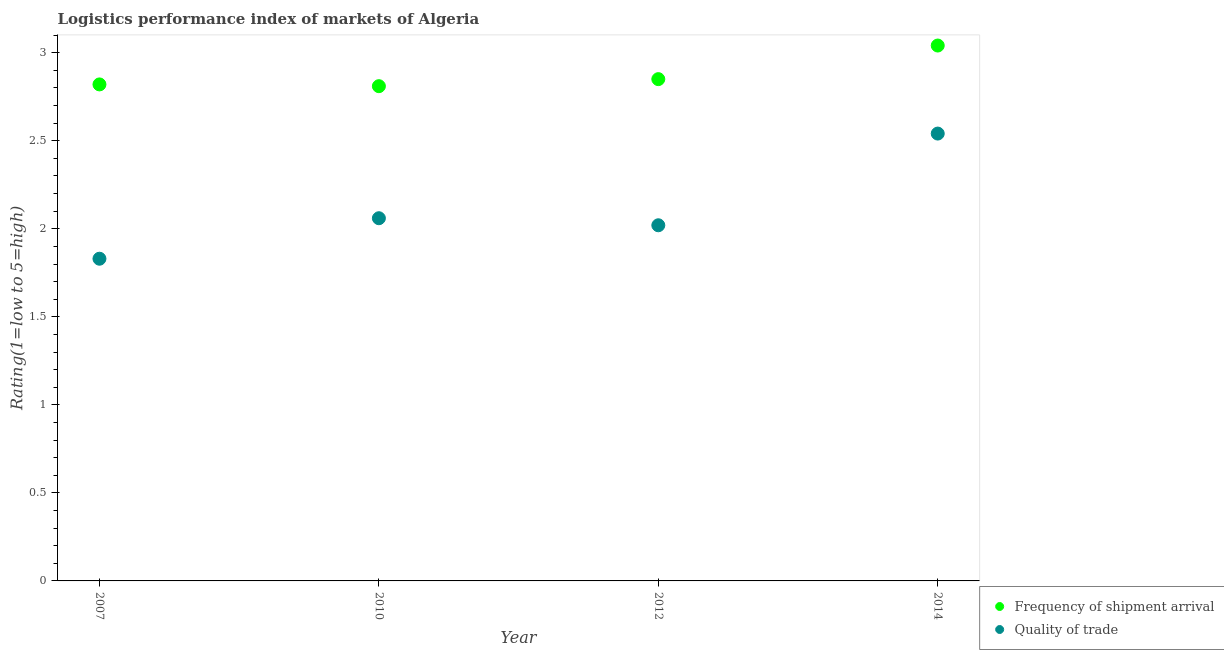How many different coloured dotlines are there?
Your response must be concise. 2. Is the number of dotlines equal to the number of legend labels?
Give a very brief answer. Yes. What is the lpi quality of trade in 2014?
Provide a short and direct response. 2.54. Across all years, what is the maximum lpi quality of trade?
Offer a terse response. 2.54. Across all years, what is the minimum lpi quality of trade?
Provide a short and direct response. 1.83. What is the total lpi of frequency of shipment arrival in the graph?
Provide a short and direct response. 11.52. What is the difference between the lpi of frequency of shipment arrival in 2012 and that in 2014?
Your answer should be compact. -0.19. What is the difference between the lpi quality of trade in 2010 and the lpi of frequency of shipment arrival in 2014?
Make the answer very short. -0.98. What is the average lpi quality of trade per year?
Offer a terse response. 2.11. In the year 2012, what is the difference between the lpi of frequency of shipment arrival and lpi quality of trade?
Provide a succinct answer. 0.83. What is the ratio of the lpi quality of trade in 2007 to that in 2014?
Make the answer very short. 0.72. Is the lpi quality of trade in 2007 less than that in 2012?
Offer a terse response. Yes. What is the difference between the highest and the second highest lpi of frequency of shipment arrival?
Give a very brief answer. 0.19. What is the difference between the highest and the lowest lpi of frequency of shipment arrival?
Make the answer very short. 0.23. Is the lpi quality of trade strictly greater than the lpi of frequency of shipment arrival over the years?
Keep it short and to the point. No. Is the lpi quality of trade strictly less than the lpi of frequency of shipment arrival over the years?
Offer a very short reply. Yes. How many dotlines are there?
Offer a terse response. 2. How many years are there in the graph?
Provide a short and direct response. 4. Does the graph contain any zero values?
Keep it short and to the point. No. Where does the legend appear in the graph?
Keep it short and to the point. Bottom right. How are the legend labels stacked?
Keep it short and to the point. Vertical. What is the title of the graph?
Offer a very short reply. Logistics performance index of markets of Algeria. What is the label or title of the X-axis?
Offer a terse response. Year. What is the label or title of the Y-axis?
Your answer should be very brief. Rating(1=low to 5=high). What is the Rating(1=low to 5=high) of Frequency of shipment arrival in 2007?
Give a very brief answer. 2.82. What is the Rating(1=low to 5=high) in Quality of trade in 2007?
Your answer should be compact. 1.83. What is the Rating(1=low to 5=high) in Frequency of shipment arrival in 2010?
Ensure brevity in your answer.  2.81. What is the Rating(1=low to 5=high) of Quality of trade in 2010?
Give a very brief answer. 2.06. What is the Rating(1=low to 5=high) of Frequency of shipment arrival in 2012?
Your response must be concise. 2.85. What is the Rating(1=low to 5=high) of Quality of trade in 2012?
Offer a terse response. 2.02. What is the Rating(1=low to 5=high) in Frequency of shipment arrival in 2014?
Provide a succinct answer. 3.04. What is the Rating(1=low to 5=high) in Quality of trade in 2014?
Give a very brief answer. 2.54. Across all years, what is the maximum Rating(1=low to 5=high) of Frequency of shipment arrival?
Provide a succinct answer. 3.04. Across all years, what is the maximum Rating(1=low to 5=high) of Quality of trade?
Make the answer very short. 2.54. Across all years, what is the minimum Rating(1=low to 5=high) in Frequency of shipment arrival?
Your answer should be very brief. 2.81. Across all years, what is the minimum Rating(1=low to 5=high) in Quality of trade?
Your answer should be very brief. 1.83. What is the total Rating(1=low to 5=high) of Frequency of shipment arrival in the graph?
Make the answer very short. 11.52. What is the total Rating(1=low to 5=high) in Quality of trade in the graph?
Make the answer very short. 8.45. What is the difference between the Rating(1=low to 5=high) in Quality of trade in 2007 and that in 2010?
Your response must be concise. -0.23. What is the difference between the Rating(1=low to 5=high) in Frequency of shipment arrival in 2007 and that in 2012?
Your answer should be very brief. -0.03. What is the difference between the Rating(1=low to 5=high) of Quality of trade in 2007 and that in 2012?
Provide a short and direct response. -0.19. What is the difference between the Rating(1=low to 5=high) of Frequency of shipment arrival in 2007 and that in 2014?
Your answer should be very brief. -0.22. What is the difference between the Rating(1=low to 5=high) of Quality of trade in 2007 and that in 2014?
Provide a short and direct response. -0.71. What is the difference between the Rating(1=low to 5=high) of Frequency of shipment arrival in 2010 and that in 2012?
Your response must be concise. -0.04. What is the difference between the Rating(1=low to 5=high) of Quality of trade in 2010 and that in 2012?
Provide a succinct answer. 0.04. What is the difference between the Rating(1=low to 5=high) in Frequency of shipment arrival in 2010 and that in 2014?
Offer a very short reply. -0.23. What is the difference between the Rating(1=low to 5=high) of Quality of trade in 2010 and that in 2014?
Offer a terse response. -0.48. What is the difference between the Rating(1=low to 5=high) of Frequency of shipment arrival in 2012 and that in 2014?
Offer a terse response. -0.19. What is the difference between the Rating(1=low to 5=high) of Quality of trade in 2012 and that in 2014?
Your answer should be compact. -0.52. What is the difference between the Rating(1=low to 5=high) in Frequency of shipment arrival in 2007 and the Rating(1=low to 5=high) in Quality of trade in 2010?
Offer a terse response. 0.76. What is the difference between the Rating(1=low to 5=high) in Frequency of shipment arrival in 2007 and the Rating(1=low to 5=high) in Quality of trade in 2014?
Your answer should be compact. 0.28. What is the difference between the Rating(1=low to 5=high) of Frequency of shipment arrival in 2010 and the Rating(1=low to 5=high) of Quality of trade in 2012?
Give a very brief answer. 0.79. What is the difference between the Rating(1=low to 5=high) in Frequency of shipment arrival in 2010 and the Rating(1=low to 5=high) in Quality of trade in 2014?
Offer a very short reply. 0.27. What is the difference between the Rating(1=low to 5=high) in Frequency of shipment arrival in 2012 and the Rating(1=low to 5=high) in Quality of trade in 2014?
Make the answer very short. 0.31. What is the average Rating(1=low to 5=high) in Frequency of shipment arrival per year?
Ensure brevity in your answer.  2.88. What is the average Rating(1=low to 5=high) in Quality of trade per year?
Keep it short and to the point. 2.11. In the year 2007, what is the difference between the Rating(1=low to 5=high) in Frequency of shipment arrival and Rating(1=low to 5=high) in Quality of trade?
Offer a very short reply. 0.99. In the year 2010, what is the difference between the Rating(1=low to 5=high) in Frequency of shipment arrival and Rating(1=low to 5=high) in Quality of trade?
Provide a short and direct response. 0.75. In the year 2012, what is the difference between the Rating(1=low to 5=high) in Frequency of shipment arrival and Rating(1=low to 5=high) in Quality of trade?
Provide a succinct answer. 0.83. In the year 2014, what is the difference between the Rating(1=low to 5=high) in Frequency of shipment arrival and Rating(1=low to 5=high) in Quality of trade?
Provide a succinct answer. 0.5. What is the ratio of the Rating(1=low to 5=high) in Quality of trade in 2007 to that in 2010?
Your answer should be very brief. 0.89. What is the ratio of the Rating(1=low to 5=high) of Frequency of shipment arrival in 2007 to that in 2012?
Make the answer very short. 0.99. What is the ratio of the Rating(1=low to 5=high) of Quality of trade in 2007 to that in 2012?
Give a very brief answer. 0.91. What is the ratio of the Rating(1=low to 5=high) of Frequency of shipment arrival in 2007 to that in 2014?
Give a very brief answer. 0.93. What is the ratio of the Rating(1=low to 5=high) in Quality of trade in 2007 to that in 2014?
Offer a very short reply. 0.72. What is the ratio of the Rating(1=low to 5=high) of Frequency of shipment arrival in 2010 to that in 2012?
Keep it short and to the point. 0.99. What is the ratio of the Rating(1=low to 5=high) of Quality of trade in 2010 to that in 2012?
Offer a terse response. 1.02. What is the ratio of the Rating(1=low to 5=high) of Frequency of shipment arrival in 2010 to that in 2014?
Provide a succinct answer. 0.92. What is the ratio of the Rating(1=low to 5=high) of Quality of trade in 2010 to that in 2014?
Make the answer very short. 0.81. What is the ratio of the Rating(1=low to 5=high) in Frequency of shipment arrival in 2012 to that in 2014?
Offer a very short reply. 0.94. What is the ratio of the Rating(1=low to 5=high) in Quality of trade in 2012 to that in 2014?
Offer a very short reply. 0.8. What is the difference between the highest and the second highest Rating(1=low to 5=high) of Frequency of shipment arrival?
Your answer should be very brief. 0.19. What is the difference between the highest and the second highest Rating(1=low to 5=high) of Quality of trade?
Give a very brief answer. 0.48. What is the difference between the highest and the lowest Rating(1=low to 5=high) in Frequency of shipment arrival?
Give a very brief answer. 0.23. What is the difference between the highest and the lowest Rating(1=low to 5=high) in Quality of trade?
Provide a succinct answer. 0.71. 